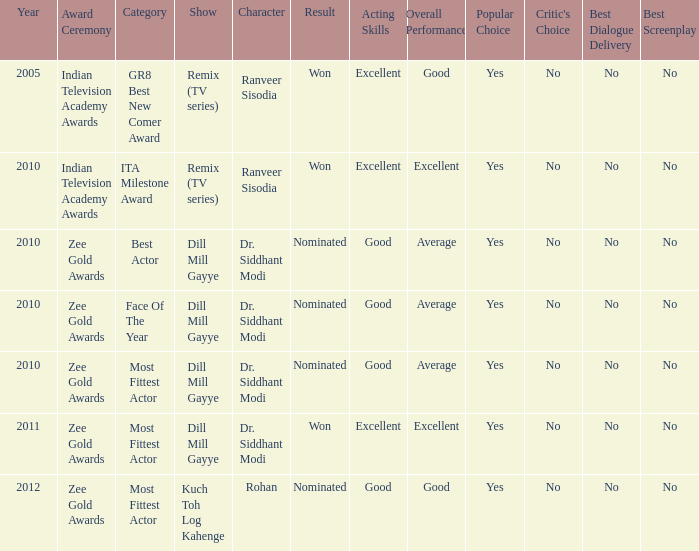Which show has a character of Rohan? Kuch Toh Log Kahenge. 